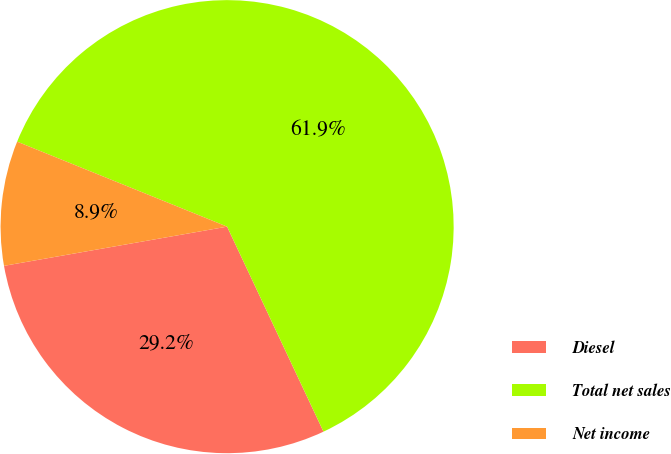<chart> <loc_0><loc_0><loc_500><loc_500><pie_chart><fcel>Diesel<fcel>Total net sales<fcel>Net income<nl><fcel>29.23%<fcel>61.89%<fcel>8.89%<nl></chart> 